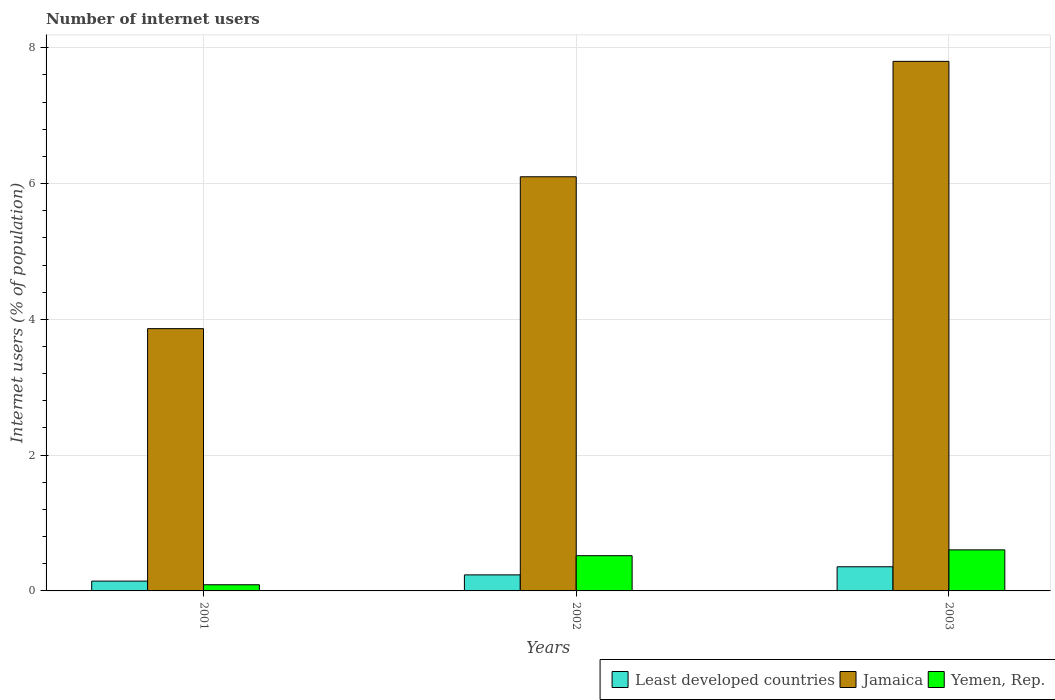Are the number of bars per tick equal to the number of legend labels?
Your response must be concise. Yes. What is the label of the 3rd group of bars from the left?
Your answer should be very brief. 2003. In how many cases, is the number of bars for a given year not equal to the number of legend labels?
Your response must be concise. 0. What is the number of internet users in Yemen, Rep. in 2001?
Give a very brief answer. 0.09. Across all years, what is the maximum number of internet users in Jamaica?
Your response must be concise. 7.8. Across all years, what is the minimum number of internet users in Least developed countries?
Your response must be concise. 0.14. In which year was the number of internet users in Jamaica minimum?
Offer a very short reply. 2001. What is the total number of internet users in Yemen, Rep. in the graph?
Make the answer very short. 1.21. What is the difference between the number of internet users in Yemen, Rep. in 2001 and that in 2002?
Make the answer very short. -0.43. What is the difference between the number of internet users in Yemen, Rep. in 2001 and the number of internet users in Least developed countries in 2002?
Keep it short and to the point. -0.15. What is the average number of internet users in Least developed countries per year?
Your response must be concise. 0.25. In the year 2003, what is the difference between the number of internet users in Yemen, Rep. and number of internet users in Least developed countries?
Offer a terse response. 0.25. What is the ratio of the number of internet users in Jamaica in 2001 to that in 2002?
Keep it short and to the point. 0.63. What is the difference between the highest and the second highest number of internet users in Jamaica?
Offer a very short reply. 1.7. What is the difference between the highest and the lowest number of internet users in Least developed countries?
Your response must be concise. 0.21. In how many years, is the number of internet users in Yemen, Rep. greater than the average number of internet users in Yemen, Rep. taken over all years?
Your answer should be very brief. 2. Is the sum of the number of internet users in Yemen, Rep. in 2002 and 2003 greater than the maximum number of internet users in Least developed countries across all years?
Your response must be concise. Yes. What does the 1st bar from the left in 2002 represents?
Provide a succinct answer. Least developed countries. What does the 3rd bar from the right in 2002 represents?
Keep it short and to the point. Least developed countries. How many bars are there?
Provide a succinct answer. 9. Are all the bars in the graph horizontal?
Your answer should be very brief. No. What is the difference between two consecutive major ticks on the Y-axis?
Make the answer very short. 2. Are the values on the major ticks of Y-axis written in scientific E-notation?
Your answer should be compact. No. Does the graph contain any zero values?
Your response must be concise. No. How are the legend labels stacked?
Your answer should be very brief. Horizontal. What is the title of the graph?
Offer a terse response. Number of internet users. Does "Chile" appear as one of the legend labels in the graph?
Keep it short and to the point. No. What is the label or title of the X-axis?
Your answer should be compact. Years. What is the label or title of the Y-axis?
Provide a short and direct response. Internet users (% of population). What is the Internet users (% of population) in Least developed countries in 2001?
Keep it short and to the point. 0.14. What is the Internet users (% of population) of Jamaica in 2001?
Offer a very short reply. 3.86. What is the Internet users (% of population) in Yemen, Rep. in 2001?
Offer a terse response. 0.09. What is the Internet users (% of population) of Least developed countries in 2002?
Your answer should be very brief. 0.24. What is the Internet users (% of population) of Yemen, Rep. in 2002?
Offer a terse response. 0.52. What is the Internet users (% of population) of Least developed countries in 2003?
Provide a short and direct response. 0.36. What is the Internet users (% of population) of Jamaica in 2003?
Your answer should be compact. 7.8. What is the Internet users (% of population) of Yemen, Rep. in 2003?
Keep it short and to the point. 0.6. Across all years, what is the maximum Internet users (% of population) in Least developed countries?
Your response must be concise. 0.36. Across all years, what is the maximum Internet users (% of population) of Yemen, Rep.?
Your answer should be very brief. 0.6. Across all years, what is the minimum Internet users (% of population) in Least developed countries?
Provide a short and direct response. 0.14. Across all years, what is the minimum Internet users (% of population) of Jamaica?
Offer a terse response. 3.86. Across all years, what is the minimum Internet users (% of population) in Yemen, Rep.?
Your answer should be compact. 0.09. What is the total Internet users (% of population) in Least developed countries in the graph?
Give a very brief answer. 0.74. What is the total Internet users (% of population) of Jamaica in the graph?
Make the answer very short. 17.76. What is the total Internet users (% of population) in Yemen, Rep. in the graph?
Your answer should be very brief. 1.21. What is the difference between the Internet users (% of population) of Least developed countries in 2001 and that in 2002?
Provide a short and direct response. -0.09. What is the difference between the Internet users (% of population) of Jamaica in 2001 and that in 2002?
Keep it short and to the point. -2.24. What is the difference between the Internet users (% of population) of Yemen, Rep. in 2001 and that in 2002?
Provide a succinct answer. -0.43. What is the difference between the Internet users (% of population) in Least developed countries in 2001 and that in 2003?
Offer a terse response. -0.21. What is the difference between the Internet users (% of population) of Jamaica in 2001 and that in 2003?
Keep it short and to the point. -3.94. What is the difference between the Internet users (% of population) in Yemen, Rep. in 2001 and that in 2003?
Provide a succinct answer. -0.51. What is the difference between the Internet users (% of population) of Least developed countries in 2002 and that in 2003?
Provide a succinct answer. -0.12. What is the difference between the Internet users (% of population) of Yemen, Rep. in 2002 and that in 2003?
Make the answer very short. -0.09. What is the difference between the Internet users (% of population) of Least developed countries in 2001 and the Internet users (% of population) of Jamaica in 2002?
Give a very brief answer. -5.96. What is the difference between the Internet users (% of population) in Least developed countries in 2001 and the Internet users (% of population) in Yemen, Rep. in 2002?
Provide a succinct answer. -0.37. What is the difference between the Internet users (% of population) of Jamaica in 2001 and the Internet users (% of population) of Yemen, Rep. in 2002?
Provide a succinct answer. 3.34. What is the difference between the Internet users (% of population) of Least developed countries in 2001 and the Internet users (% of population) of Jamaica in 2003?
Provide a short and direct response. -7.66. What is the difference between the Internet users (% of population) in Least developed countries in 2001 and the Internet users (% of population) in Yemen, Rep. in 2003?
Offer a terse response. -0.46. What is the difference between the Internet users (% of population) of Jamaica in 2001 and the Internet users (% of population) of Yemen, Rep. in 2003?
Make the answer very short. 3.26. What is the difference between the Internet users (% of population) of Least developed countries in 2002 and the Internet users (% of population) of Jamaica in 2003?
Your answer should be very brief. -7.56. What is the difference between the Internet users (% of population) in Least developed countries in 2002 and the Internet users (% of population) in Yemen, Rep. in 2003?
Keep it short and to the point. -0.37. What is the difference between the Internet users (% of population) in Jamaica in 2002 and the Internet users (% of population) in Yemen, Rep. in 2003?
Your response must be concise. 5.5. What is the average Internet users (% of population) of Least developed countries per year?
Make the answer very short. 0.25. What is the average Internet users (% of population) in Jamaica per year?
Provide a short and direct response. 5.92. What is the average Internet users (% of population) of Yemen, Rep. per year?
Offer a terse response. 0.4. In the year 2001, what is the difference between the Internet users (% of population) of Least developed countries and Internet users (% of population) of Jamaica?
Make the answer very short. -3.72. In the year 2001, what is the difference between the Internet users (% of population) in Least developed countries and Internet users (% of population) in Yemen, Rep.?
Provide a succinct answer. 0.05. In the year 2001, what is the difference between the Internet users (% of population) of Jamaica and Internet users (% of population) of Yemen, Rep.?
Make the answer very short. 3.77. In the year 2002, what is the difference between the Internet users (% of population) of Least developed countries and Internet users (% of population) of Jamaica?
Offer a terse response. -5.86. In the year 2002, what is the difference between the Internet users (% of population) of Least developed countries and Internet users (% of population) of Yemen, Rep.?
Your answer should be very brief. -0.28. In the year 2002, what is the difference between the Internet users (% of population) of Jamaica and Internet users (% of population) of Yemen, Rep.?
Give a very brief answer. 5.58. In the year 2003, what is the difference between the Internet users (% of population) of Least developed countries and Internet users (% of population) of Jamaica?
Ensure brevity in your answer.  -7.44. In the year 2003, what is the difference between the Internet users (% of population) of Least developed countries and Internet users (% of population) of Yemen, Rep.?
Give a very brief answer. -0.25. In the year 2003, what is the difference between the Internet users (% of population) in Jamaica and Internet users (% of population) in Yemen, Rep.?
Keep it short and to the point. 7.2. What is the ratio of the Internet users (% of population) in Least developed countries in 2001 to that in 2002?
Your response must be concise. 0.61. What is the ratio of the Internet users (% of population) in Jamaica in 2001 to that in 2002?
Your response must be concise. 0.63. What is the ratio of the Internet users (% of population) in Yemen, Rep. in 2001 to that in 2002?
Give a very brief answer. 0.17. What is the ratio of the Internet users (% of population) in Least developed countries in 2001 to that in 2003?
Keep it short and to the point. 0.41. What is the ratio of the Internet users (% of population) in Jamaica in 2001 to that in 2003?
Keep it short and to the point. 0.5. What is the ratio of the Internet users (% of population) of Yemen, Rep. in 2001 to that in 2003?
Your answer should be compact. 0.15. What is the ratio of the Internet users (% of population) of Least developed countries in 2002 to that in 2003?
Your answer should be very brief. 0.66. What is the ratio of the Internet users (% of population) of Jamaica in 2002 to that in 2003?
Provide a succinct answer. 0.78. What is the ratio of the Internet users (% of population) of Yemen, Rep. in 2002 to that in 2003?
Provide a succinct answer. 0.86. What is the difference between the highest and the second highest Internet users (% of population) of Least developed countries?
Offer a terse response. 0.12. What is the difference between the highest and the second highest Internet users (% of population) of Yemen, Rep.?
Provide a short and direct response. 0.09. What is the difference between the highest and the lowest Internet users (% of population) of Least developed countries?
Your answer should be compact. 0.21. What is the difference between the highest and the lowest Internet users (% of population) of Jamaica?
Your answer should be very brief. 3.94. What is the difference between the highest and the lowest Internet users (% of population) of Yemen, Rep.?
Offer a terse response. 0.51. 